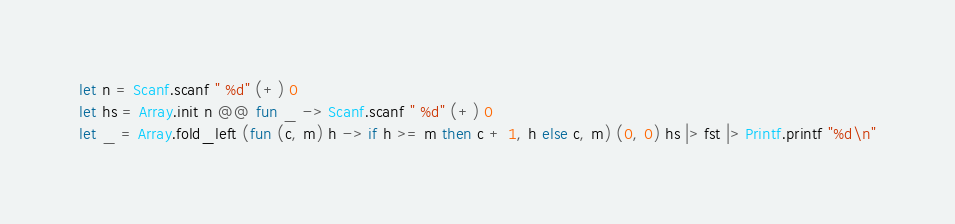<code> <loc_0><loc_0><loc_500><loc_500><_OCaml_>let n = Scanf.scanf " %d" (+) 0
let hs = Array.init n @@ fun _ -> Scanf.scanf " %d" (+) 0
let _ = Array.fold_left (fun (c, m) h -> if h >= m then c + 1, h else c, m) (0, 0) hs |> fst |> Printf.printf "%d\n"</code> 